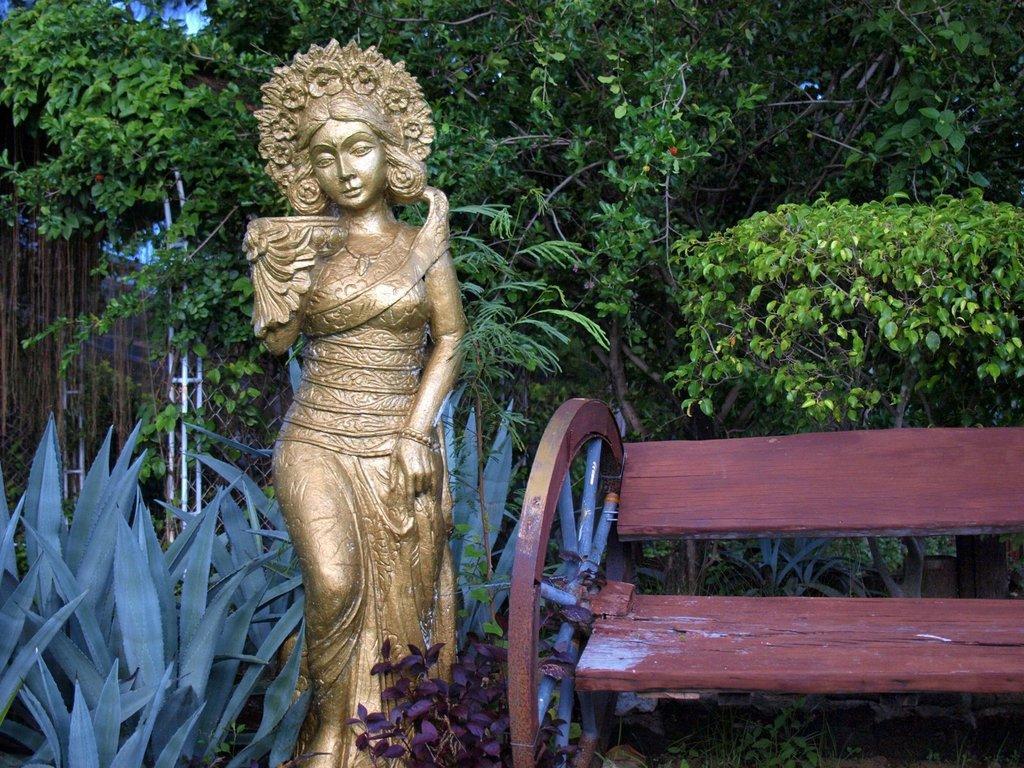Can you describe this image briefly? The image is clicked in the garden. In the front there is a idol in golden color. To the right there is a bench made up of wood. In the background there are trees and plants. 